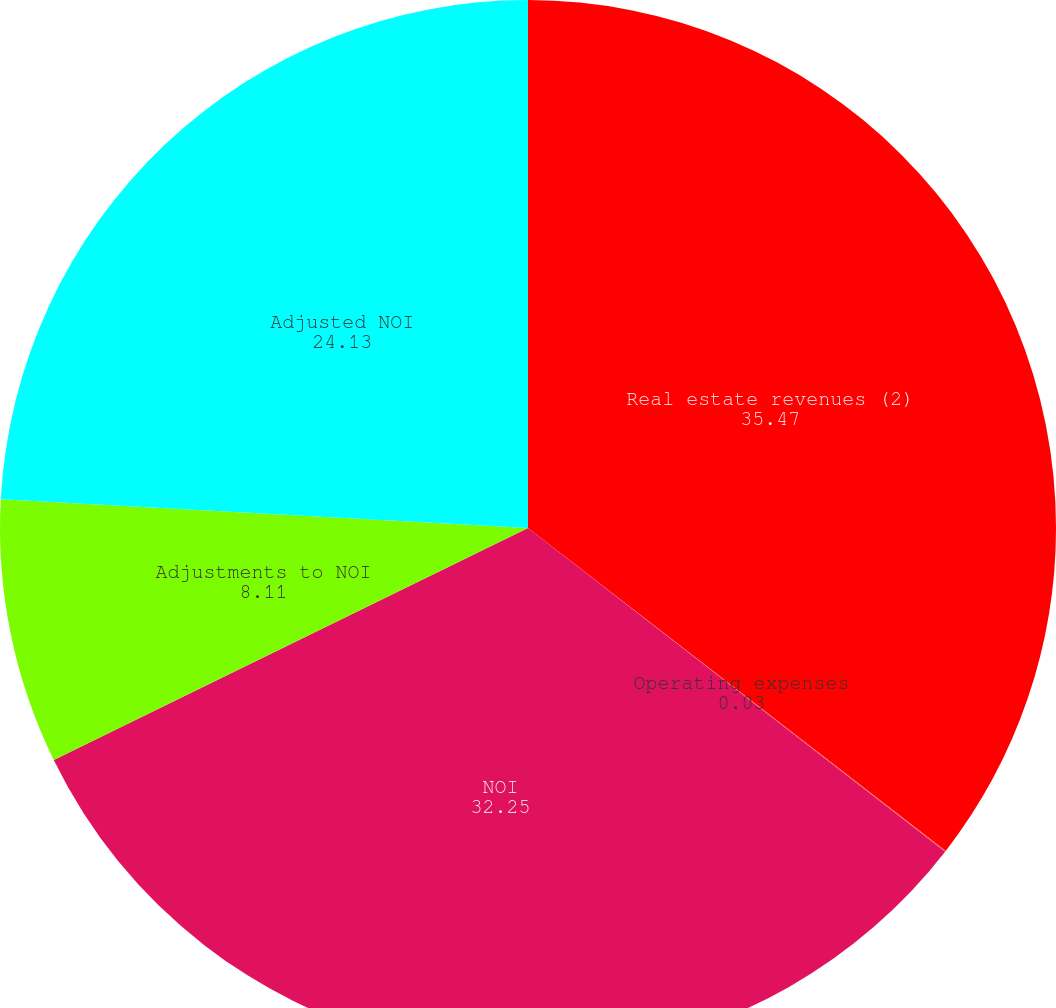<chart> <loc_0><loc_0><loc_500><loc_500><pie_chart><fcel>Real estate revenues (2)<fcel>Operating expenses<fcel>NOI<fcel>Adjustments to NOI<fcel>Adjusted NOI<nl><fcel>35.47%<fcel>0.03%<fcel>32.25%<fcel>8.11%<fcel>24.13%<nl></chart> 